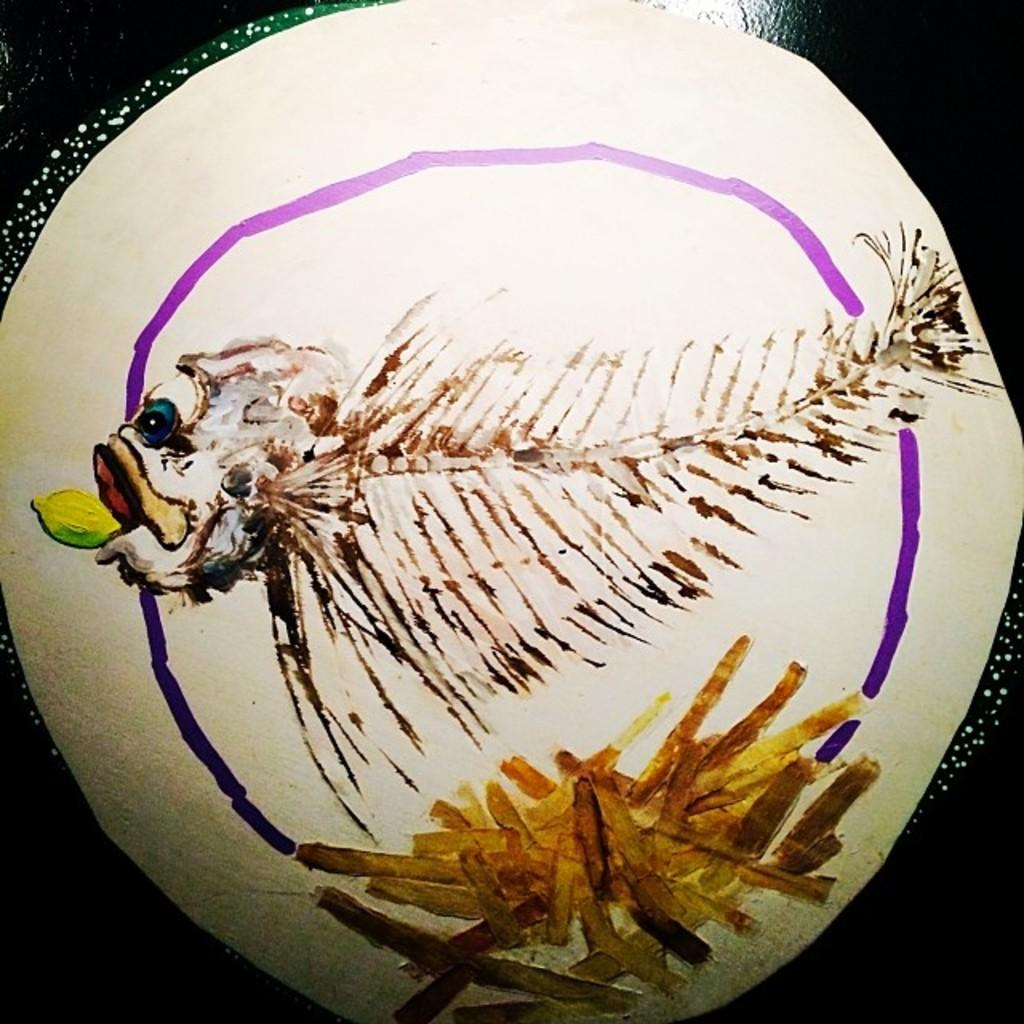What is the texture of the crack in the middle of the image? Since there are no facts about the image, we cannot determine the texture of any cracks or the presence of a middle section in the image. 